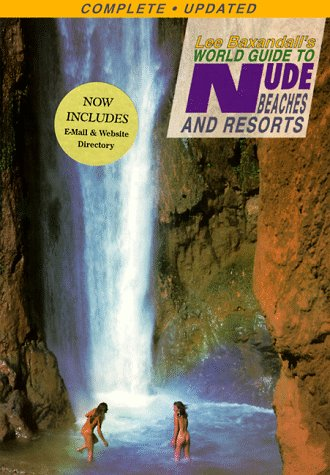What is the genre of this book? This book belongs to the travel genre, specifically catering to those interested in nude beaches and resorts around the world. 